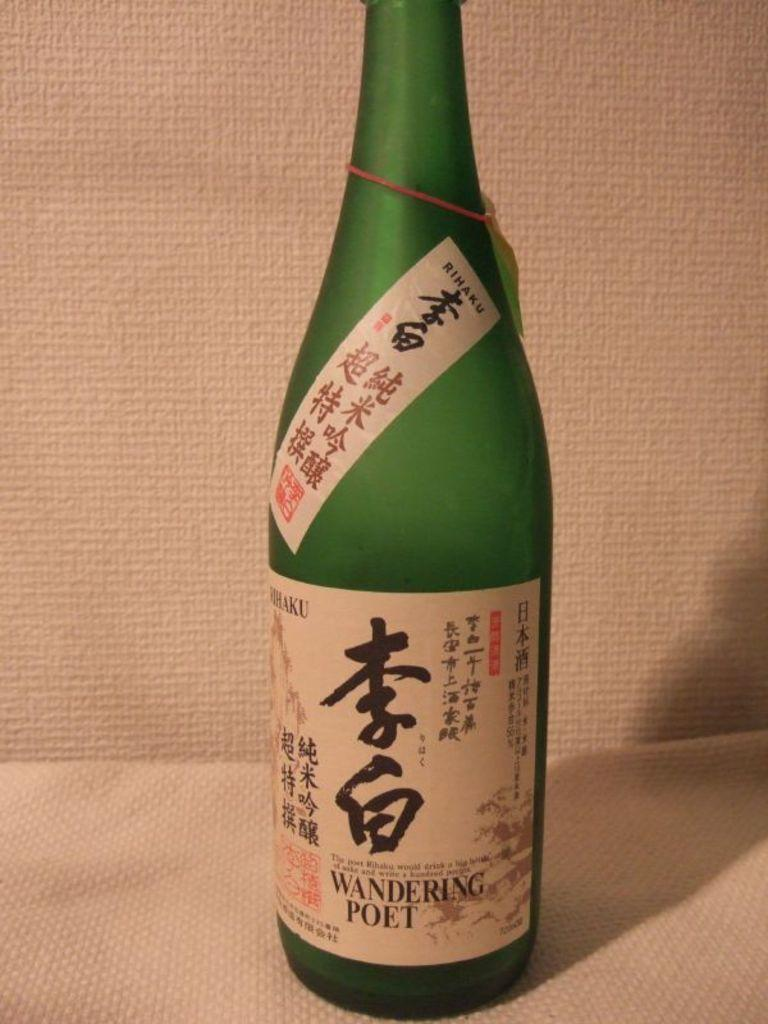<image>
Present a compact description of the photo's key features. A bottle of alcohol that is called Wandering Poet 